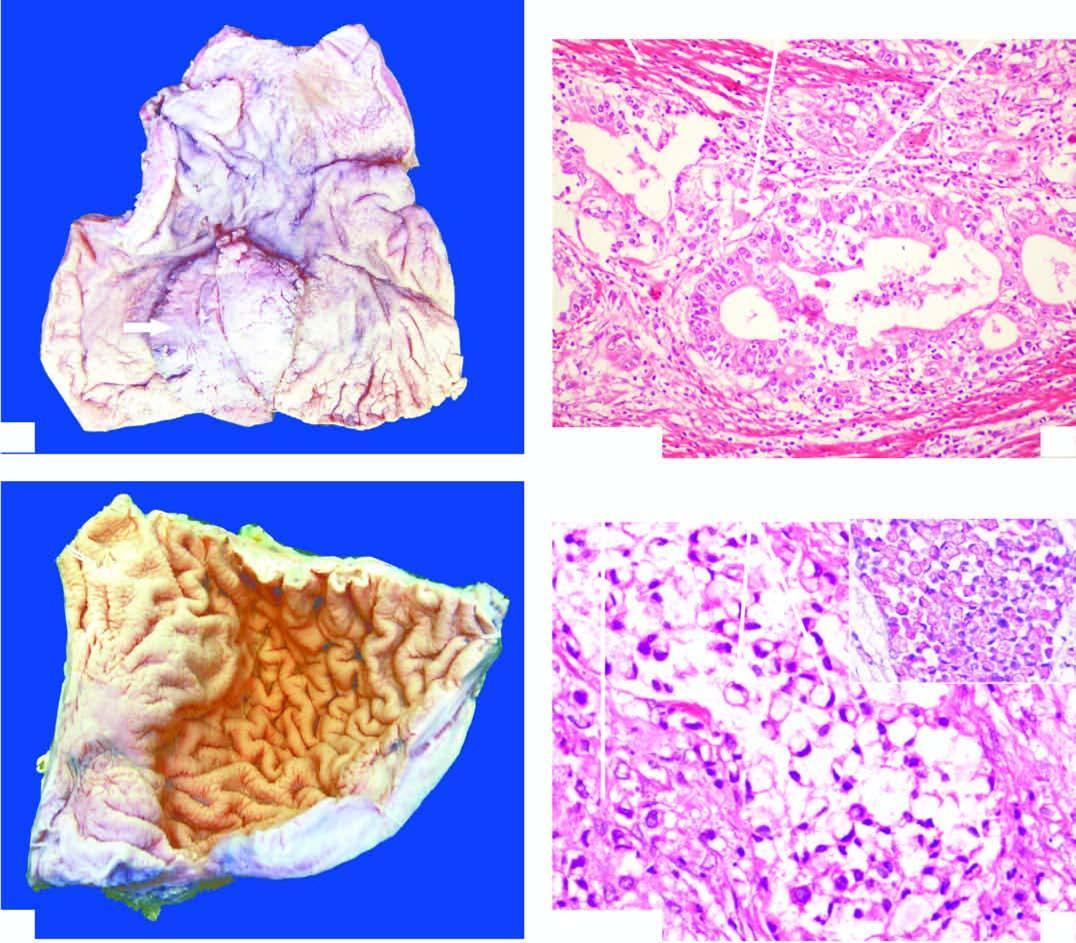s the background markedly thickened?
Answer the question using a single word or phrase. No 